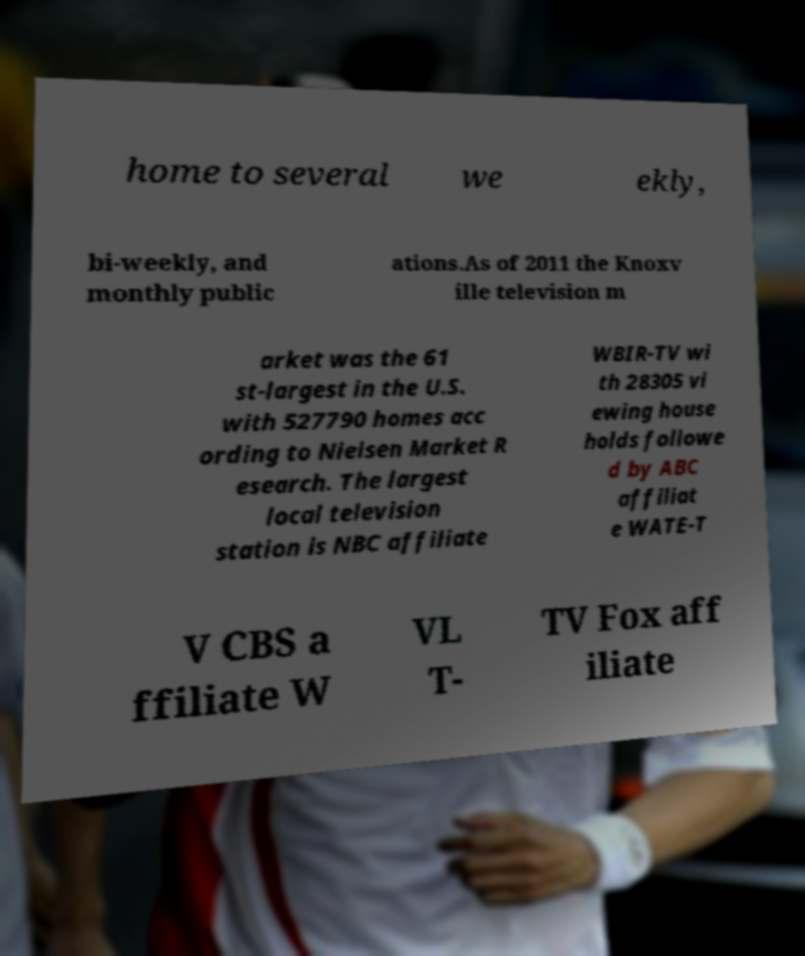Can you accurately transcribe the text from the provided image for me? home to several we ekly, bi-weekly, and monthly public ations.As of 2011 the Knoxv ille television m arket was the 61 st-largest in the U.S. with 527790 homes acc ording to Nielsen Market R esearch. The largest local television station is NBC affiliate WBIR-TV wi th 28305 vi ewing house holds followe d by ABC affiliat e WATE-T V CBS a ffiliate W VL T- TV Fox aff iliate 